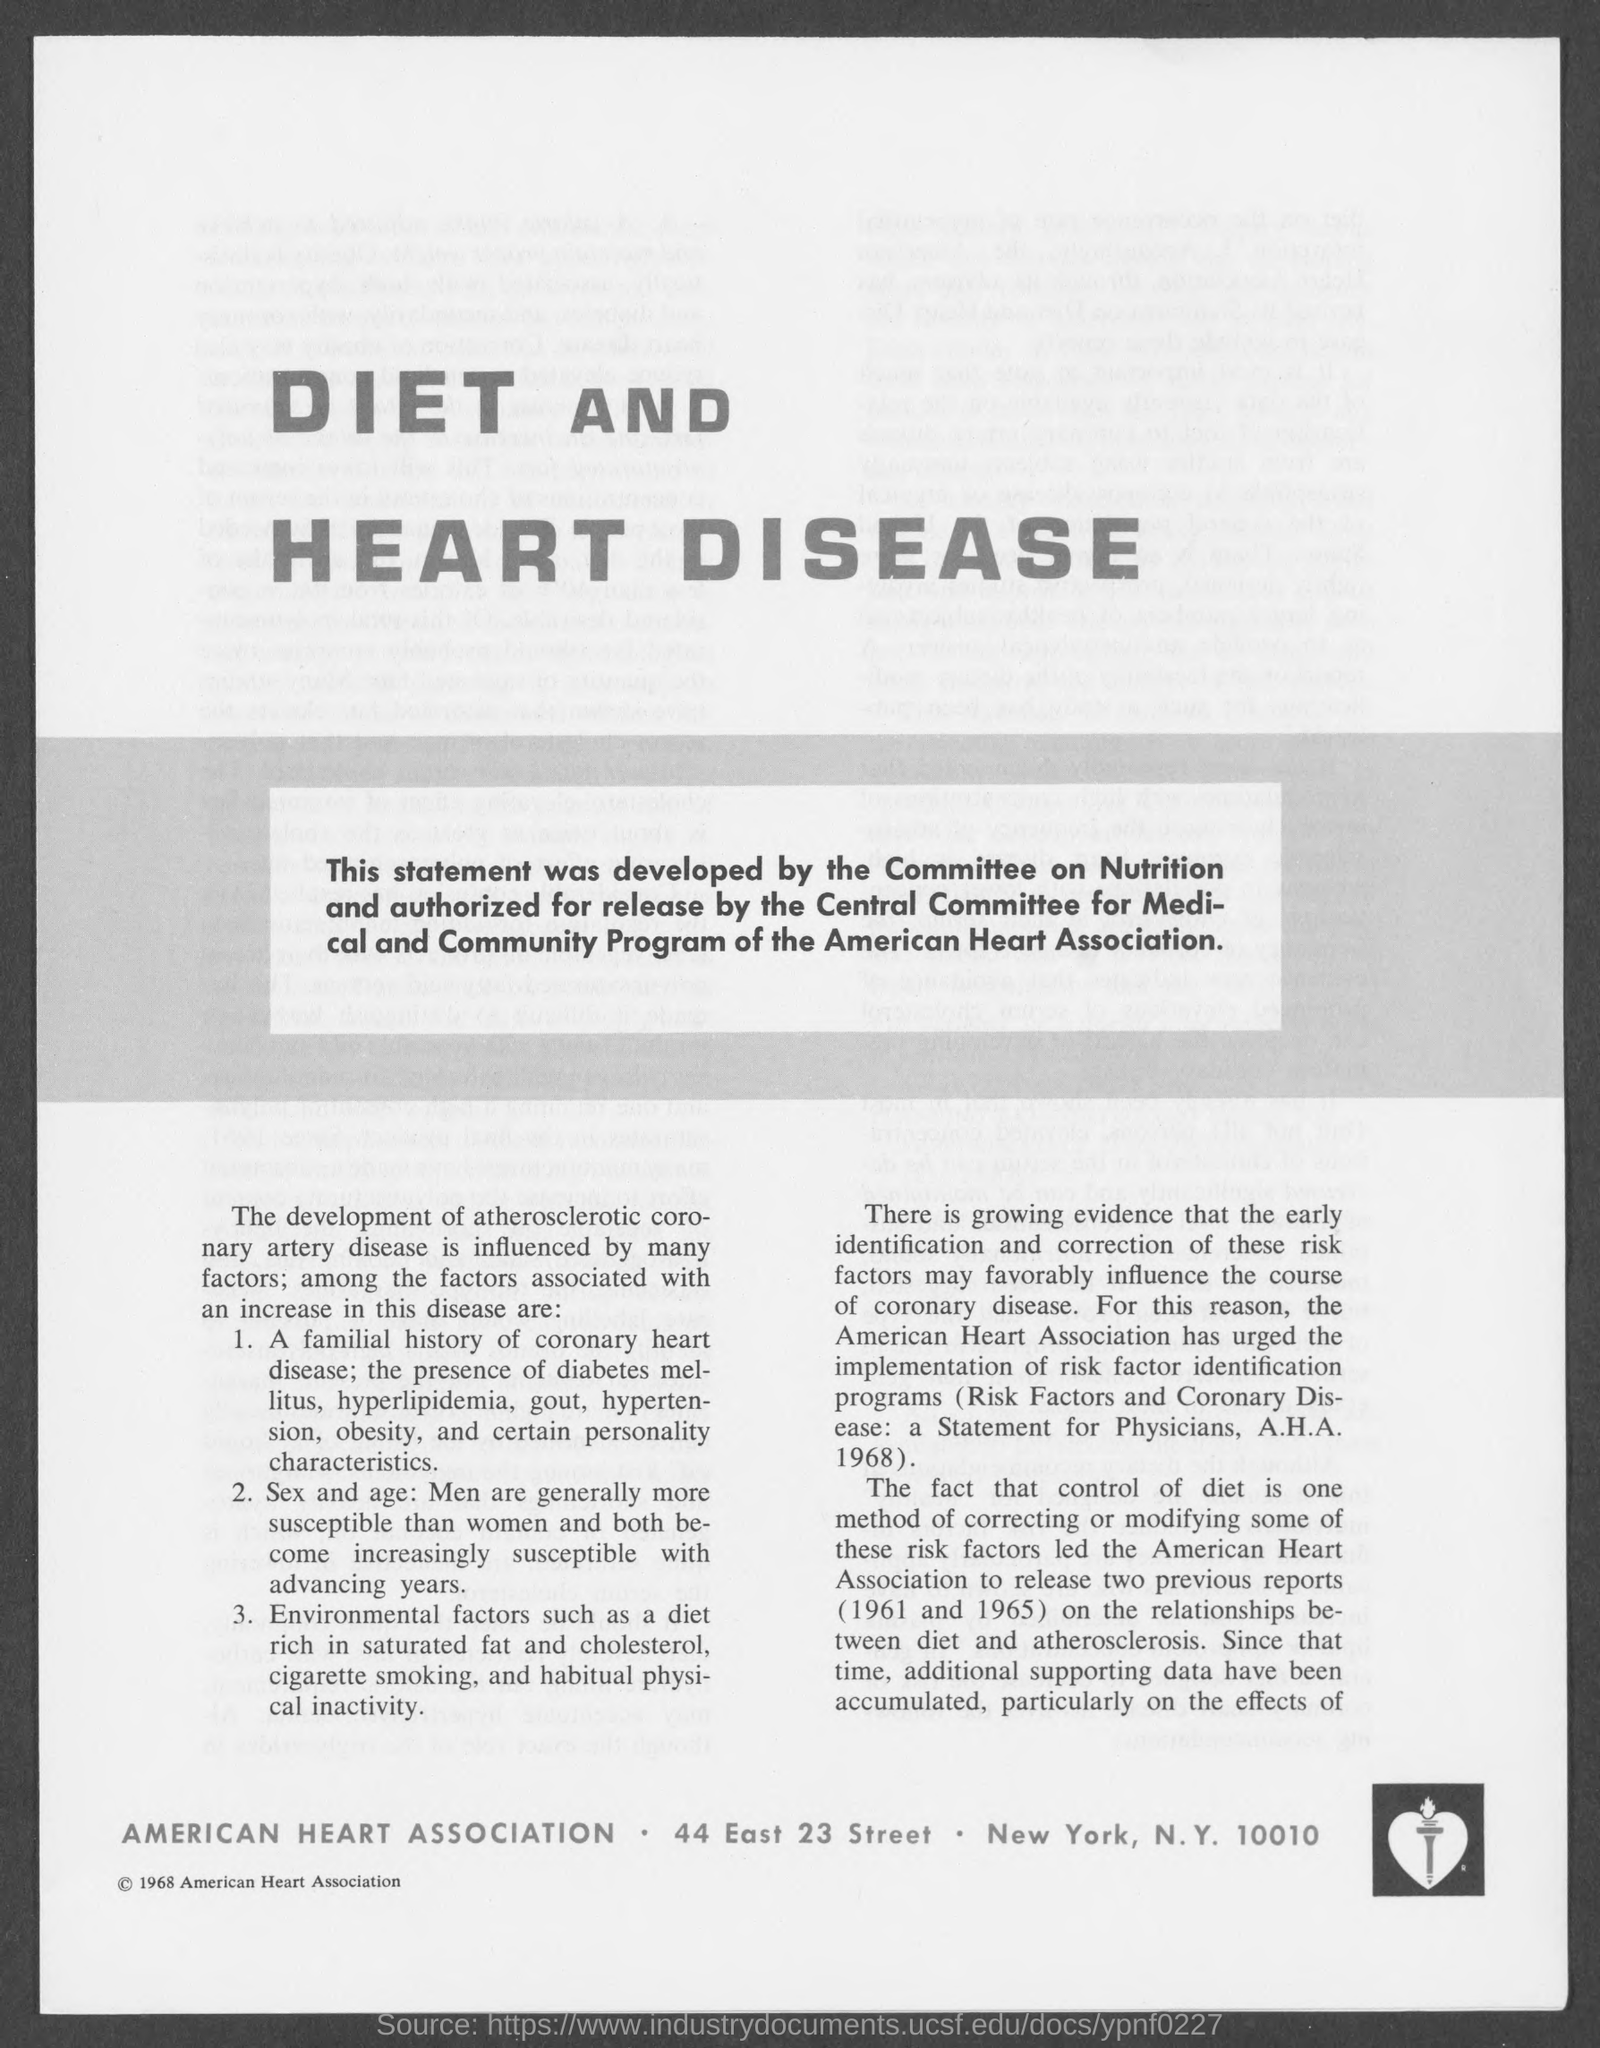In which city is american heart association located ?
Your answer should be very brief. New York. 